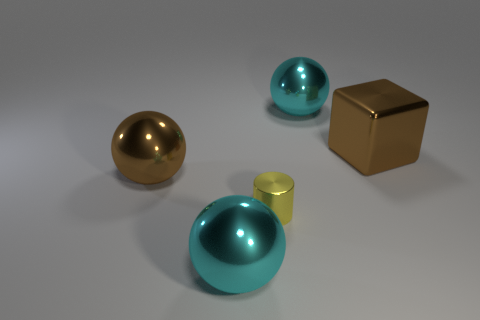There is a cyan thing that is on the right side of the yellow metallic cylinder; what number of shiny balls are left of it?
Provide a succinct answer. 2. There is a cyan sphere that is in front of the cyan object right of the tiny cylinder; is there a large ball that is in front of it?
Offer a terse response. No. Is there anything else that is made of the same material as the big brown sphere?
Provide a short and direct response. Yes. Are the small yellow object and the big sphere right of the small metal thing made of the same material?
Provide a short and direct response. Yes. What is the shape of the big metallic thing that is on the left side of the object in front of the yellow object?
Your answer should be very brief. Sphere. How many large things are either brown spheres or cyan objects?
Make the answer very short. 3. What number of large cyan metallic objects have the same shape as the tiny yellow metallic object?
Offer a terse response. 0. There is a small object; is its shape the same as the large brown shiny thing in front of the shiny cube?
Keep it short and to the point. No. What number of large brown objects are in front of the brown metallic ball?
Your answer should be very brief. 0. Are there any purple rubber things of the same size as the yellow shiny object?
Ensure brevity in your answer.  No. 